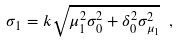Convert formula to latex. <formula><loc_0><loc_0><loc_500><loc_500>\sigma _ { 1 } = k \sqrt { \mu _ { 1 } ^ { 2 } \sigma _ { 0 } ^ { 2 } + \delta _ { 0 } ^ { 2 } \sigma _ { \mu _ { 1 } } ^ { 2 } } \ ,</formula> 